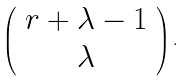<formula> <loc_0><loc_0><loc_500><loc_500>\left ( \begin{array} { c } r + \lambda - 1 \\ \lambda \end{array} \right ) .</formula> 